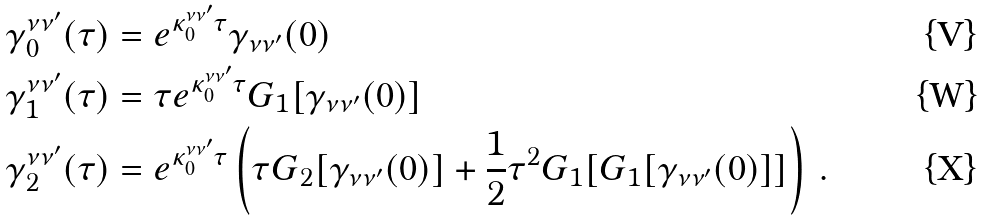<formula> <loc_0><loc_0><loc_500><loc_500>\gamma ^ { \nu \nu ^ { \prime } } _ { 0 } ( \tau ) & = e ^ { \kappa ^ { \nu \nu ^ { \prime } } _ { 0 } \tau } \gamma _ { \nu \nu ^ { \prime } } ( 0 ) \\ \gamma ^ { \nu \nu ^ { \prime } } _ { 1 } ( \tau ) & = \tau e ^ { \kappa ^ { \nu \nu ^ { \prime } } _ { 0 } \tau } G _ { 1 } [ \gamma _ { \nu \nu ^ { \prime } } ( 0 ) ] \\ \gamma ^ { \nu \nu ^ { \prime } } _ { 2 } ( \tau ) & = e ^ { \kappa ^ { \nu \nu ^ { \prime } } _ { 0 } \tau } \left ( \tau G _ { 2 } [ \gamma _ { \nu \nu ^ { \prime } } ( 0 ) ] + \frac { 1 } { 2 } \tau ^ { 2 } G _ { 1 } [ G _ { 1 } [ \gamma _ { \nu \nu ^ { \prime } } ( 0 ) ] ] \right ) \, .</formula> 